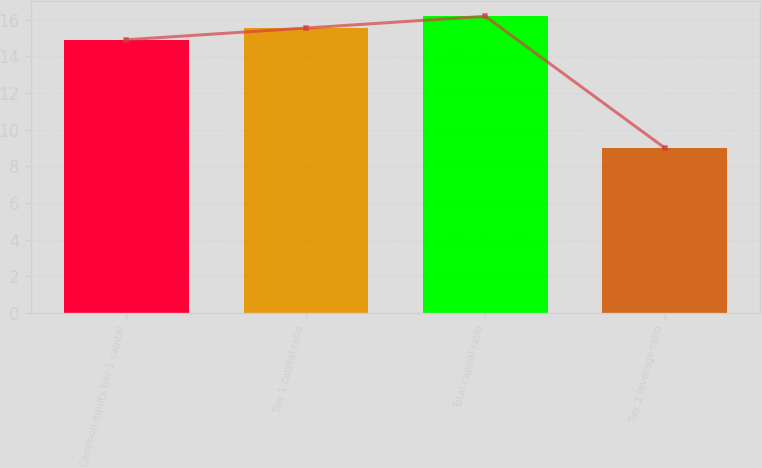Convert chart. <chart><loc_0><loc_0><loc_500><loc_500><bar_chart><fcel>Common equity tier 1 capital<fcel>Tier 1 capital ratio<fcel>Total capital ratio<fcel>Tier 1 leverage ratio<nl><fcel>14.9<fcel>15.54<fcel>16.18<fcel>9<nl></chart> 